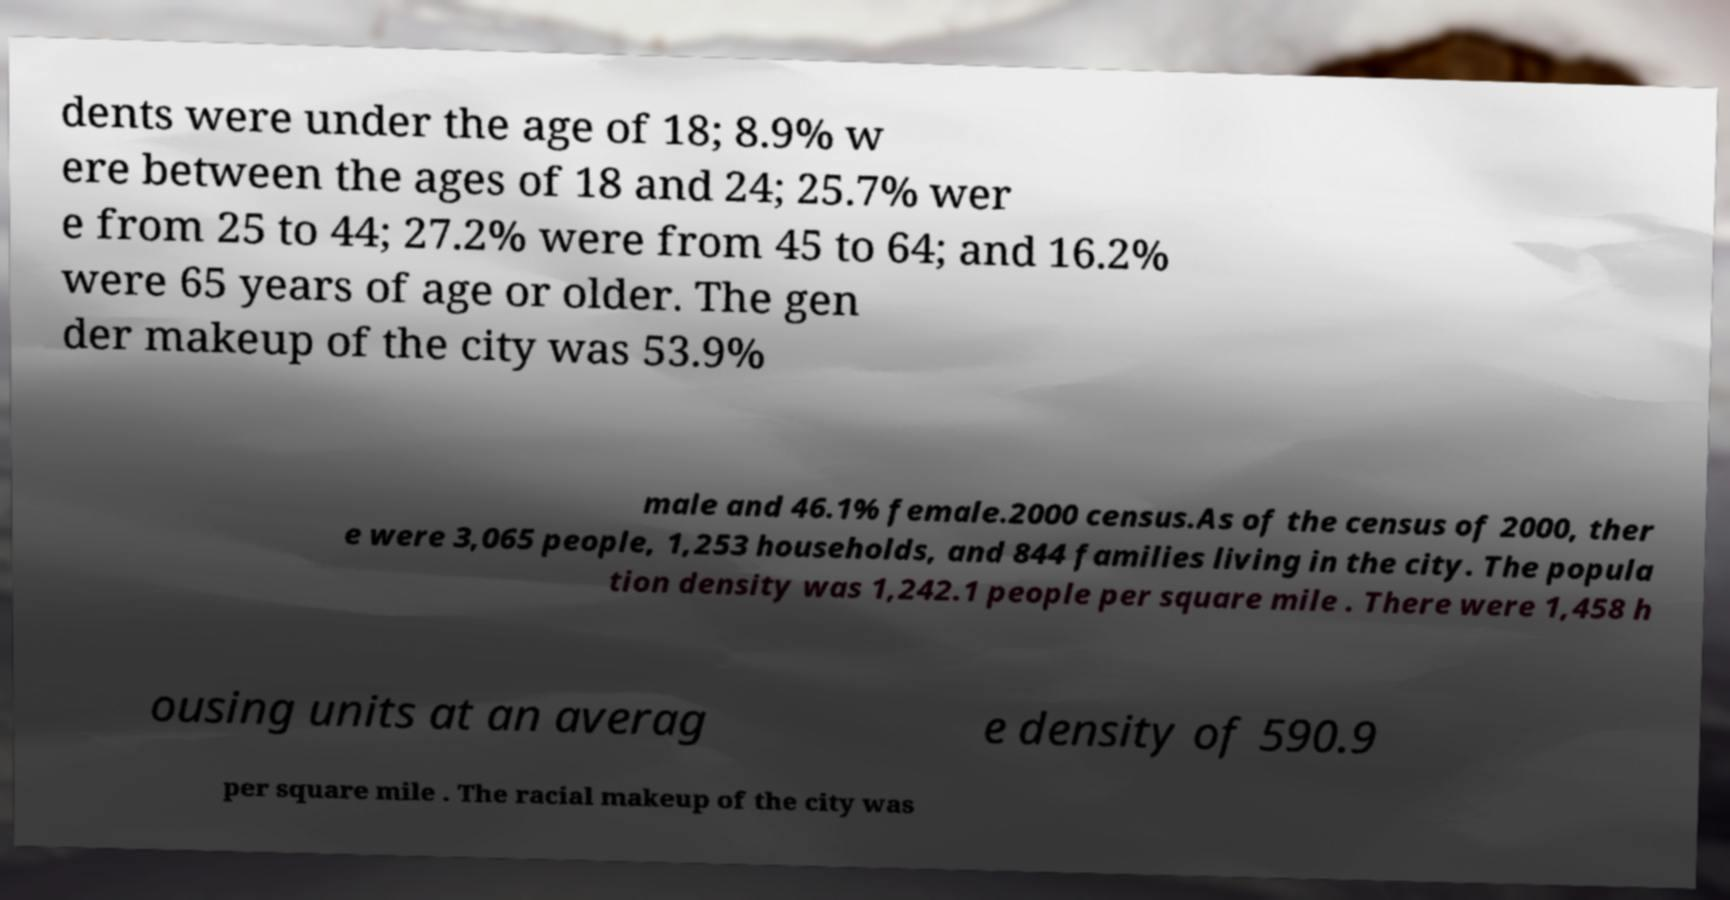Can you accurately transcribe the text from the provided image for me? dents were under the age of 18; 8.9% w ere between the ages of 18 and 24; 25.7% wer e from 25 to 44; 27.2% were from 45 to 64; and 16.2% were 65 years of age or older. The gen der makeup of the city was 53.9% male and 46.1% female.2000 census.As of the census of 2000, ther e were 3,065 people, 1,253 households, and 844 families living in the city. The popula tion density was 1,242.1 people per square mile . There were 1,458 h ousing units at an averag e density of 590.9 per square mile . The racial makeup of the city was 